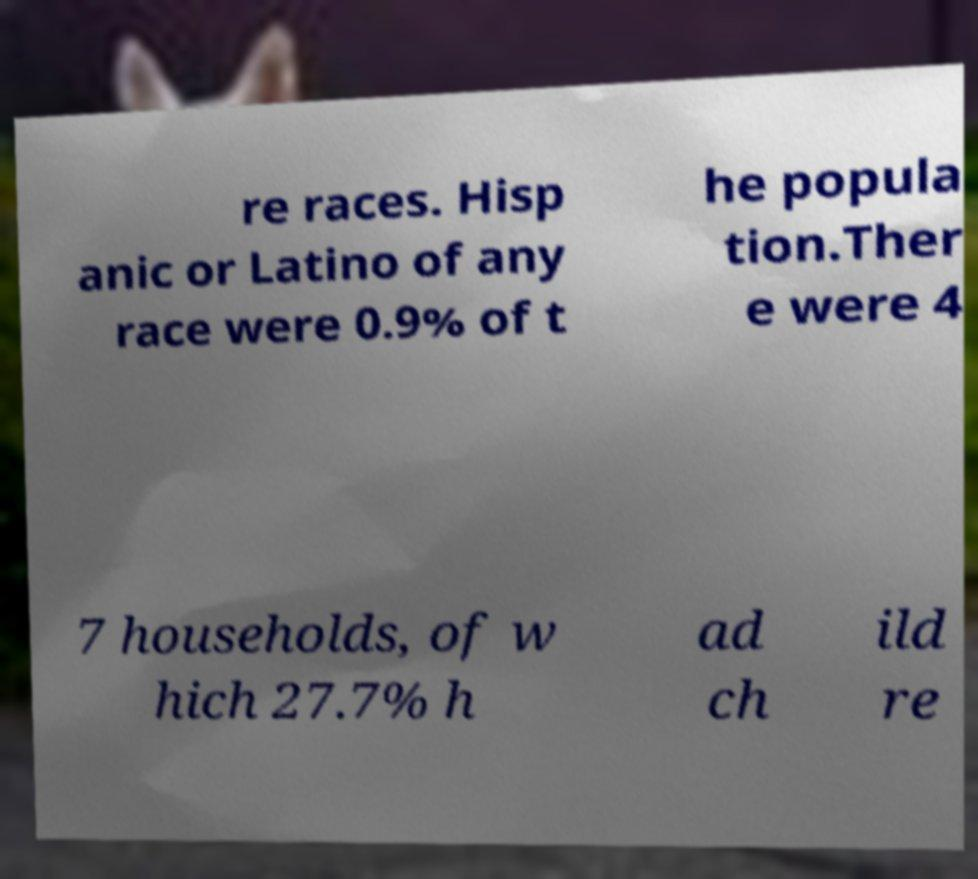Could you assist in decoding the text presented in this image and type it out clearly? re races. Hisp anic or Latino of any race were 0.9% of t he popula tion.Ther e were 4 7 households, of w hich 27.7% h ad ch ild re 